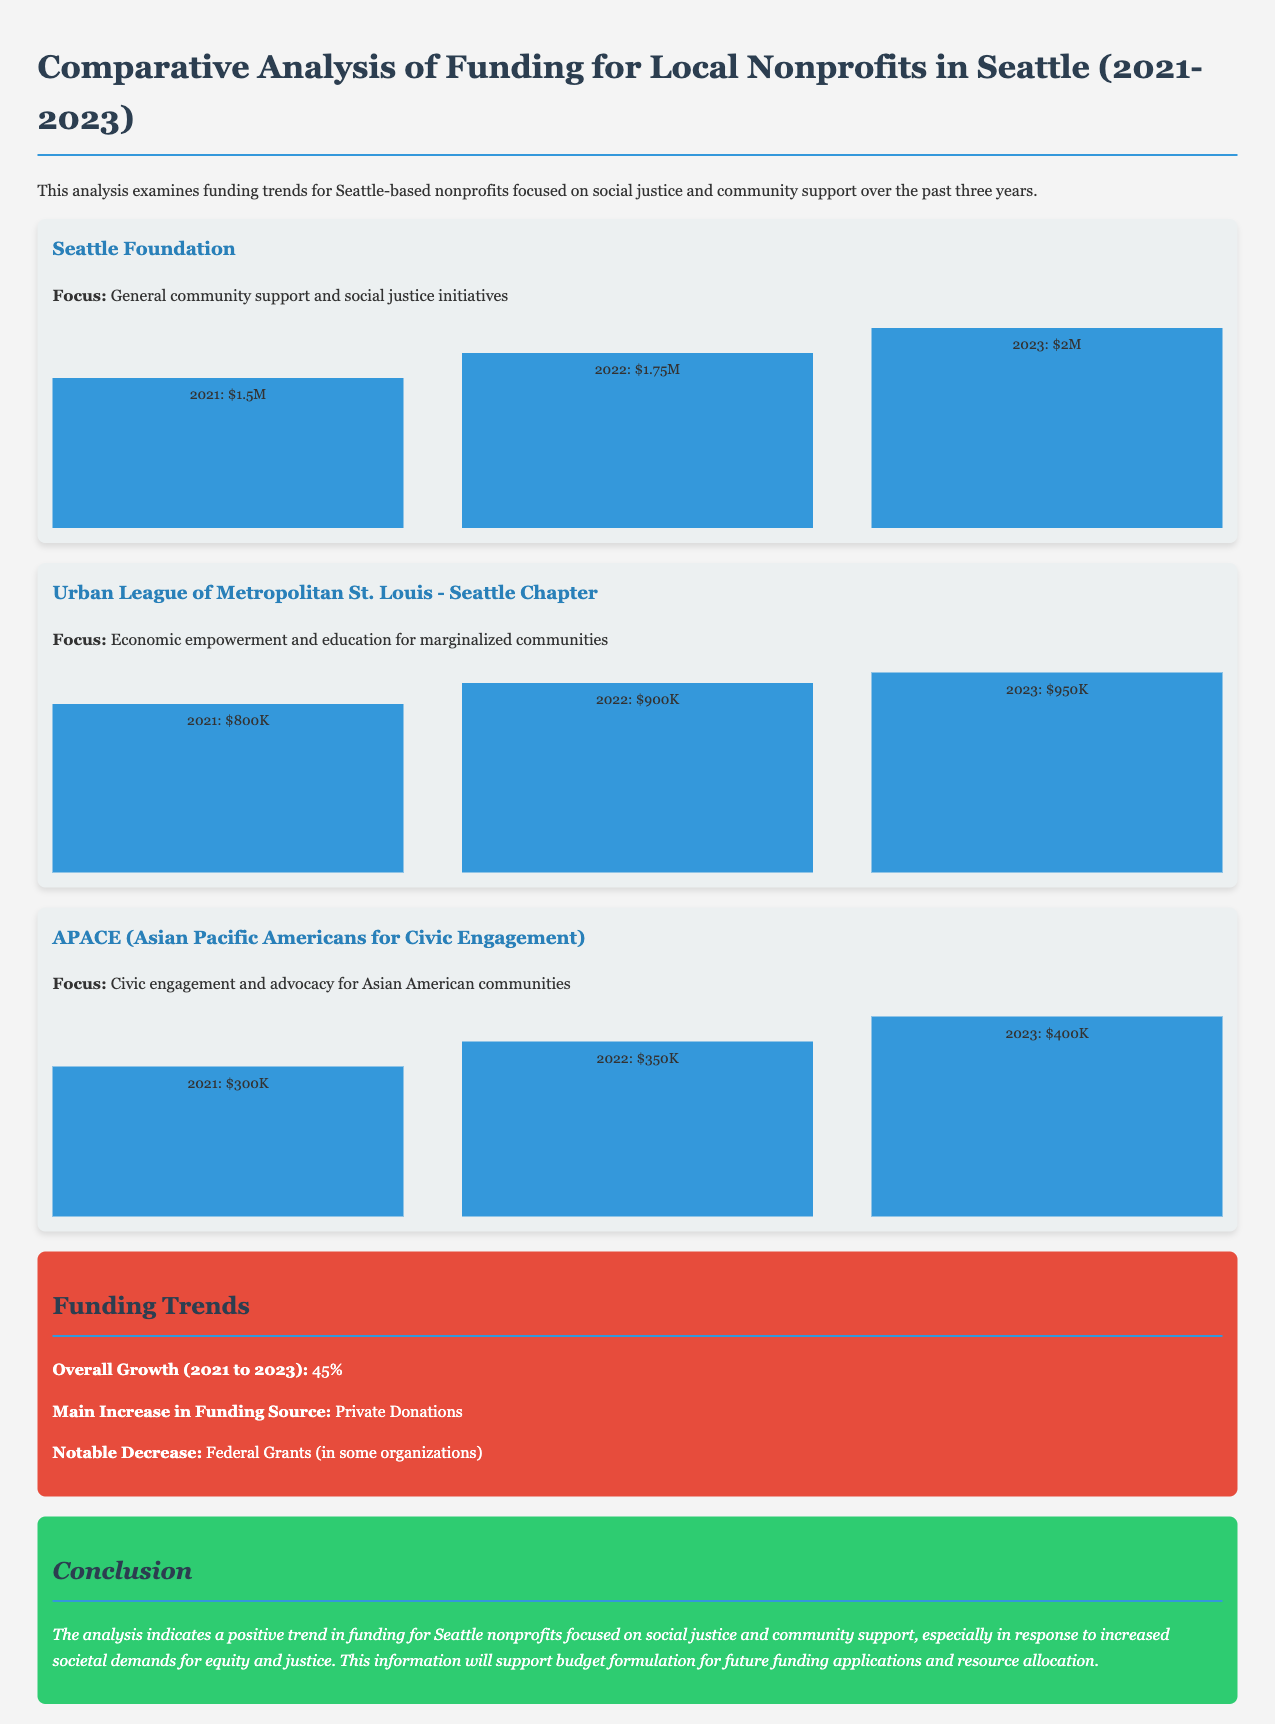What was the funding amount for Seattle Foundation in 2022? The document states that the funding for Seattle Foundation in 2022 was $1.75 million.
Answer: $1.75M What focus area does the Urban League of Metropolitan St. Louis target? According to the document, the Urban League of Metropolitan St. Louis focuses on economic empowerment and education for marginalized communities.
Answer: Economic empowerment and education for marginalized communities What was the total percentage growth in funding from 2021 to 2023? The overall growth from 2021 to 2023 mentioned in the document is 45%.
Answer: 45% Which organization received the least funding in 2021? The document indicates that APACE received the least funding among the listed organizations in 2021, which was $300,000.
Answer: $300K What is the primary source of funding increase noted in the document? The document highlights that the main increase in funding source is from private donations.
Answer: Private Donations What year did APACE reach $400,000 in funding? The document specifies that APACE achieved $400,000 in funding in 2023.
Answer: 2023 Which nonprofit experienced a notable decrease in federal grants? The document indicates that some organizations faced a notable decrease in federal grants without specifying which ones.
Answer: Some organizations What is the conclusion's main takeaway regarding nonprofit funding? The conclusion emphasizes a positive trend in funding for Seattle nonprofits focused on social justice and community support.
Answer: Positive trend in funding 